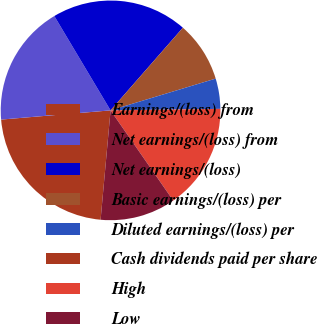Convert chart to OTSL. <chart><loc_0><loc_0><loc_500><loc_500><pie_chart><fcel>Earnings/(loss) from<fcel>Net earnings/(loss) from<fcel>Net earnings/(loss)<fcel>Basic earnings/(loss) per<fcel>Diluted earnings/(loss) per<fcel>Cash dividends paid per share<fcel>High<fcel>Low<nl><fcel>22.22%<fcel>17.78%<fcel>20.0%<fcel>8.89%<fcel>4.45%<fcel>0.01%<fcel>15.55%<fcel>11.11%<nl></chart> 